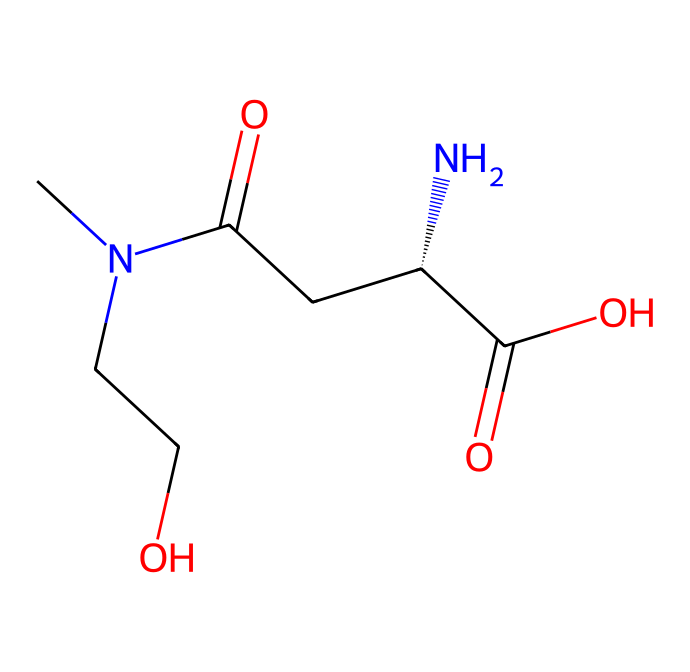What is the molecular formula of L-theanine? To find the molecular formula, we can analyze the SMILES representation for each element. The representation shows one nitrogen (N), two carbons in the main chain (C), one carbonyl (C=O), an amide (N(C)), two additional carbons (CC), and other functional groups. Counting all the atoms yields the formula C7H14N2O3.
Answer: C7H14N2O3 How many nitrogen atoms are present in the structure? By inspecting the SMILES representation, we can see there are two instances of the letter 'N.' This indicates that there are two nitrogen atoms in the structure.
Answer: 2 What type of compound is L-theanine primarily considered? L-theanine is classified as an amino acid due to the presence of both an amino group (NH2) and a carboxylic acid (COOH) in its structure. This dual functionality indicates its role as an amino acid.
Answer: amino acid Which part of the structure is responsible for promoting relaxation? The presence of the amino group and the specific arrangement of the side chains in L-theanine contribute to its function in promoting relaxation by influencing neurotransmitter levels. The complex interaction of the nitrogen atoms showcases its role in neurotransmission.
Answer: amino group What is the total number of carbon atoms in the compound? Counting the carbon atoms from the SMILES representation reveals there are seven carbon atoms in the overall structure of L-theanine, identifiable in various functionalities including the carboxylic acid and carbonyl groups.
Answer: 7 Is this compound hydrophilic or hydrophobic? The presence of multiple polar functional groups like the amino and carboxylic acid groups indicates that L-theanine is hydrophilic, allowing it to dissolve in water and interact with polar solvents.
Answer: hydrophilic 